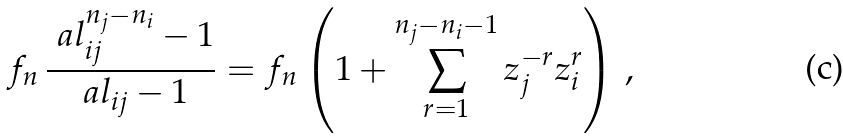<formula> <loc_0><loc_0><loc_500><loc_500>f _ { n } \, \frac { \ a l _ { i j } ^ { n _ { j } - n _ { i } } - 1 } { \ a l _ { i j } - 1 } = f _ { n } \left ( 1 + \sum _ { r = 1 } ^ { n _ { j } - n _ { i } - 1 } z _ { j } ^ { - r } z _ { i } ^ { r } \right ) \, ,</formula> 